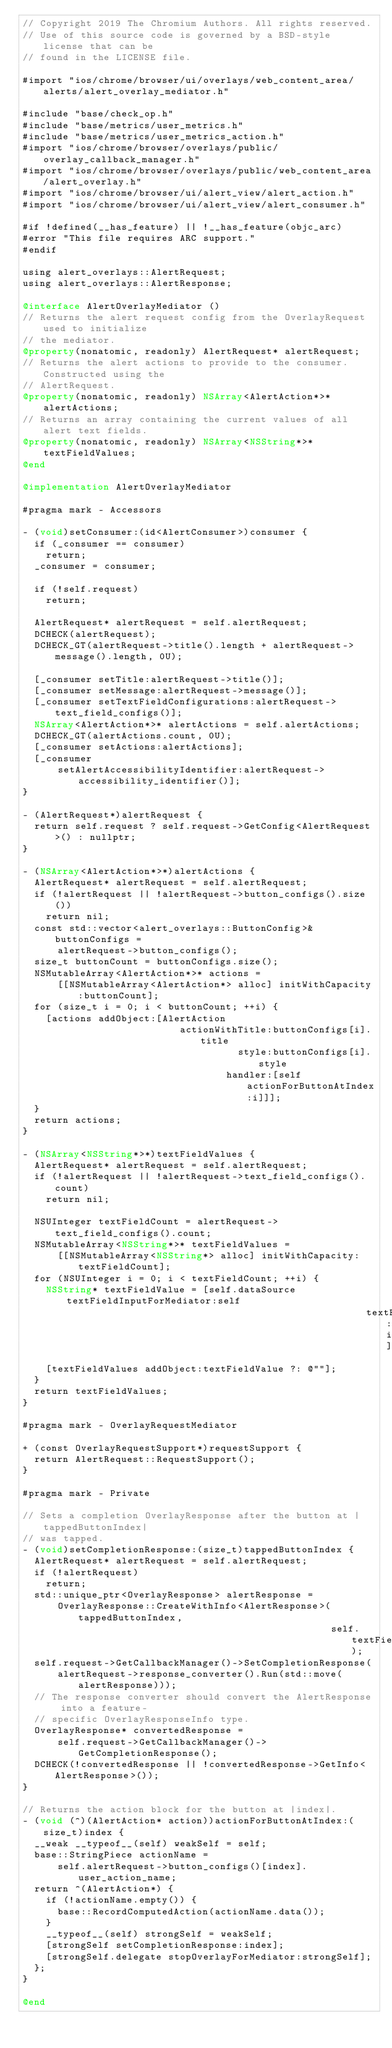Convert code to text. <code><loc_0><loc_0><loc_500><loc_500><_ObjectiveC_>// Copyright 2019 The Chromium Authors. All rights reserved.
// Use of this source code is governed by a BSD-style license that can be
// found in the LICENSE file.

#import "ios/chrome/browser/ui/overlays/web_content_area/alerts/alert_overlay_mediator.h"

#include "base/check_op.h"
#include "base/metrics/user_metrics.h"
#include "base/metrics/user_metrics_action.h"
#import "ios/chrome/browser/overlays/public/overlay_callback_manager.h"
#import "ios/chrome/browser/overlays/public/web_content_area/alert_overlay.h"
#import "ios/chrome/browser/ui/alert_view/alert_action.h"
#import "ios/chrome/browser/ui/alert_view/alert_consumer.h"

#if !defined(__has_feature) || !__has_feature(objc_arc)
#error "This file requires ARC support."
#endif

using alert_overlays::AlertRequest;
using alert_overlays::AlertResponse;

@interface AlertOverlayMediator ()
// Returns the alert request config from the OverlayRequest used to initialize
// the mediator.
@property(nonatomic, readonly) AlertRequest* alertRequest;
// Returns the alert actions to provide to the consumer.  Constructed using the
// AlertRequest.
@property(nonatomic, readonly) NSArray<AlertAction*>* alertActions;
// Returns an array containing the current values of all alert text fields.
@property(nonatomic, readonly) NSArray<NSString*>* textFieldValues;
@end

@implementation AlertOverlayMediator

#pragma mark - Accessors

- (void)setConsumer:(id<AlertConsumer>)consumer {
  if (_consumer == consumer)
    return;
  _consumer = consumer;

  if (!self.request)
    return;

  AlertRequest* alertRequest = self.alertRequest;
  DCHECK(alertRequest);
  DCHECK_GT(alertRequest->title().length + alertRequest->message().length, 0U);

  [_consumer setTitle:alertRequest->title()];
  [_consumer setMessage:alertRequest->message()];
  [_consumer setTextFieldConfigurations:alertRequest->text_field_configs()];
  NSArray<AlertAction*>* alertActions = self.alertActions;
  DCHECK_GT(alertActions.count, 0U);
  [_consumer setActions:alertActions];
  [_consumer
      setAlertAccessibilityIdentifier:alertRequest->accessibility_identifier()];
}

- (AlertRequest*)alertRequest {
  return self.request ? self.request->GetConfig<AlertRequest>() : nullptr;
}

- (NSArray<AlertAction*>*)alertActions {
  AlertRequest* alertRequest = self.alertRequest;
  if (!alertRequest || !alertRequest->button_configs().size())
    return nil;
  const std::vector<alert_overlays::ButtonConfig>& buttonConfigs =
      alertRequest->button_configs();
  size_t buttonCount = buttonConfigs.size();
  NSMutableArray<AlertAction*>* actions =
      [[NSMutableArray<AlertAction*> alloc] initWithCapacity:buttonCount];
  for (size_t i = 0; i < buttonCount; ++i) {
    [actions addObject:[AlertAction
                           actionWithTitle:buttonConfigs[i].title
                                     style:buttonConfigs[i].style
                                   handler:[self actionForButtonAtIndex:i]]];
  }
  return actions;
}

- (NSArray<NSString*>*)textFieldValues {
  AlertRequest* alertRequest = self.alertRequest;
  if (!alertRequest || !alertRequest->text_field_configs().count)
    return nil;

  NSUInteger textFieldCount = alertRequest->text_field_configs().count;
  NSMutableArray<NSString*>* textFieldValues =
      [[NSMutableArray<NSString*> alloc] initWithCapacity:textFieldCount];
  for (NSUInteger i = 0; i < textFieldCount; ++i) {
    NSString* textFieldValue = [self.dataSource textFieldInputForMediator:self
                                                           textFieldIndex:i];
    [textFieldValues addObject:textFieldValue ?: @""];
  }
  return textFieldValues;
}

#pragma mark - OverlayRequestMediator

+ (const OverlayRequestSupport*)requestSupport {
  return AlertRequest::RequestSupport();
}

#pragma mark - Private

// Sets a completion OverlayResponse after the button at |tappedButtonIndex|
// was tapped.
- (void)setCompletionResponse:(size_t)tappedButtonIndex {
  AlertRequest* alertRequest = self.alertRequest;
  if (!alertRequest)
    return;
  std::unique_ptr<OverlayResponse> alertResponse =
      OverlayResponse::CreateWithInfo<AlertResponse>(tappedButtonIndex,
                                                     self.textFieldValues);
  self.request->GetCallbackManager()->SetCompletionResponse(
      alertRequest->response_converter().Run(std::move(alertResponse)));
  // The response converter should convert the AlertResponse into a feature-
  // specific OverlayResponseInfo type.
  OverlayResponse* convertedResponse =
      self.request->GetCallbackManager()->GetCompletionResponse();
  DCHECK(!convertedResponse || !convertedResponse->GetInfo<AlertResponse>());
}

// Returns the action block for the button at |index|.
- (void (^)(AlertAction* action))actionForButtonAtIndex:(size_t)index {
  __weak __typeof__(self) weakSelf = self;
  base::StringPiece actionName =
      self.alertRequest->button_configs()[index].user_action_name;
  return ^(AlertAction*) {
    if (!actionName.empty()) {
      base::RecordComputedAction(actionName.data());
    }
    __typeof__(self) strongSelf = weakSelf;
    [strongSelf setCompletionResponse:index];
    [strongSelf.delegate stopOverlayForMediator:strongSelf];
  };
}

@end
</code> 